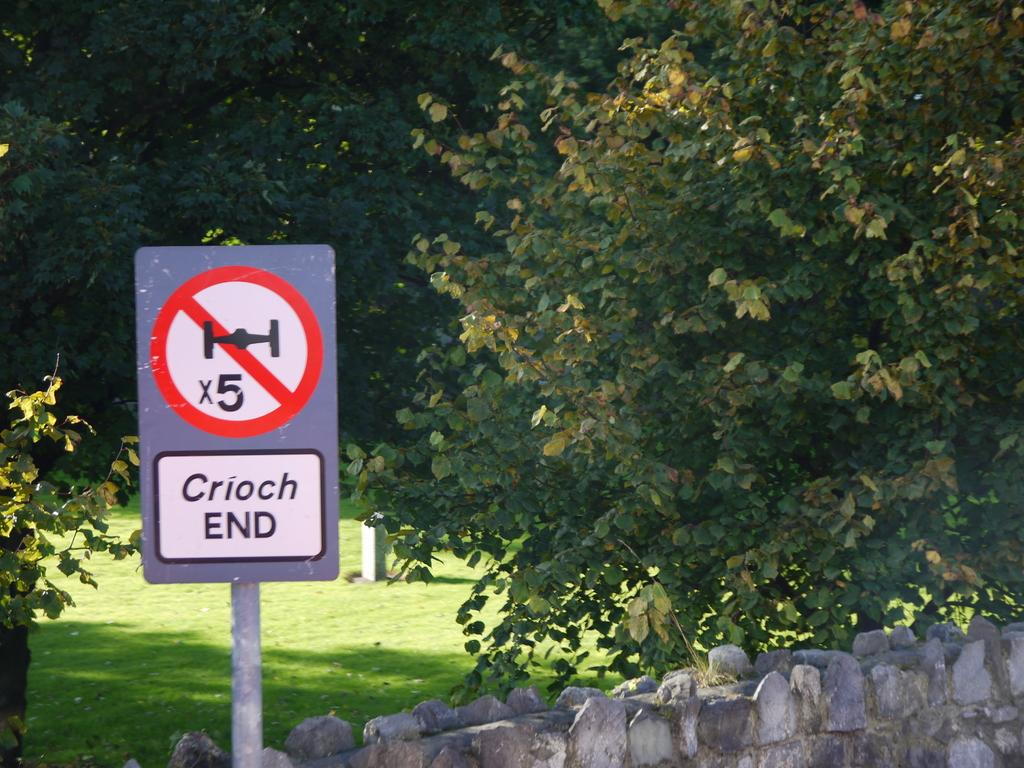<image>
Render a clear and concise summary of the photo. A sign in front of a stone wall has a red circle crossing out an image, with the words Croich End underneath. 